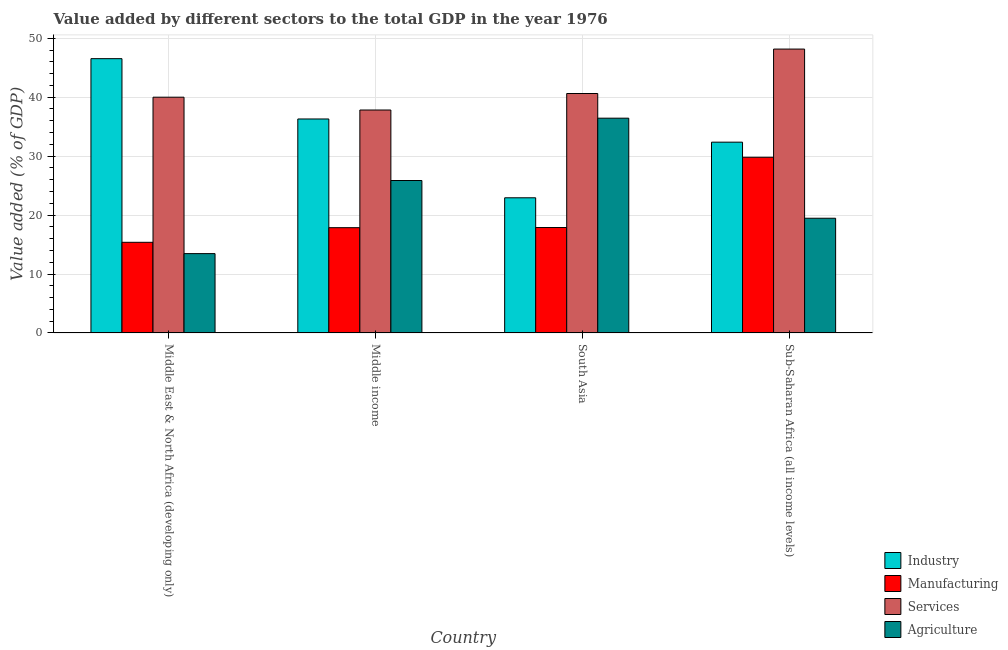Are the number of bars per tick equal to the number of legend labels?
Your answer should be compact. Yes. How many bars are there on the 2nd tick from the right?
Ensure brevity in your answer.  4. What is the label of the 4th group of bars from the left?
Provide a succinct answer. Sub-Saharan Africa (all income levels). What is the value added by manufacturing sector in Middle income?
Offer a very short reply. 17.86. Across all countries, what is the maximum value added by industrial sector?
Offer a very short reply. 46.54. Across all countries, what is the minimum value added by manufacturing sector?
Ensure brevity in your answer.  15.38. In which country was the value added by services sector maximum?
Your response must be concise. Sub-Saharan Africa (all income levels). What is the total value added by agricultural sector in the graph?
Make the answer very short. 95.23. What is the difference between the value added by services sector in Middle East & North Africa (developing only) and that in Sub-Saharan Africa (all income levels)?
Your answer should be compact. -8.17. What is the difference between the value added by industrial sector in Middle income and the value added by services sector in Middle East & North Africa (developing only)?
Your response must be concise. -3.69. What is the average value added by manufacturing sector per country?
Your answer should be very brief. 20.23. What is the difference between the value added by manufacturing sector and value added by agricultural sector in Middle income?
Your answer should be very brief. -8.01. What is the ratio of the value added by services sector in Middle income to that in South Asia?
Your answer should be very brief. 0.93. Is the difference between the value added by services sector in Middle income and Sub-Saharan Africa (all income levels) greater than the difference between the value added by industrial sector in Middle income and Sub-Saharan Africa (all income levels)?
Ensure brevity in your answer.  No. What is the difference between the highest and the second highest value added by services sector?
Offer a very short reply. 7.54. What is the difference between the highest and the lowest value added by manufacturing sector?
Ensure brevity in your answer.  14.43. In how many countries, is the value added by industrial sector greater than the average value added by industrial sector taken over all countries?
Your response must be concise. 2. What does the 1st bar from the left in Middle East & North Africa (developing only) represents?
Offer a very short reply. Industry. What does the 4th bar from the right in South Asia represents?
Your response must be concise. Industry. Is it the case that in every country, the sum of the value added by industrial sector and value added by manufacturing sector is greater than the value added by services sector?
Your response must be concise. Yes. How many bars are there?
Provide a short and direct response. 16. Does the graph contain any zero values?
Provide a succinct answer. No. How many legend labels are there?
Keep it short and to the point. 4. What is the title of the graph?
Provide a succinct answer. Value added by different sectors to the total GDP in the year 1976. What is the label or title of the X-axis?
Ensure brevity in your answer.  Country. What is the label or title of the Y-axis?
Offer a terse response. Value added (% of GDP). What is the Value added (% of GDP) of Industry in Middle East & North Africa (developing only)?
Make the answer very short. 46.54. What is the Value added (% of GDP) in Manufacturing in Middle East & North Africa (developing only)?
Give a very brief answer. 15.38. What is the Value added (% of GDP) in Services in Middle East & North Africa (developing only)?
Your answer should be compact. 40. What is the Value added (% of GDP) of Agriculture in Middle East & North Africa (developing only)?
Keep it short and to the point. 13.46. What is the Value added (% of GDP) in Industry in Middle income?
Your answer should be very brief. 36.31. What is the Value added (% of GDP) in Manufacturing in Middle income?
Your answer should be compact. 17.86. What is the Value added (% of GDP) in Services in Middle income?
Provide a short and direct response. 37.83. What is the Value added (% of GDP) in Agriculture in Middle income?
Offer a very short reply. 25.87. What is the Value added (% of GDP) of Industry in South Asia?
Offer a terse response. 22.93. What is the Value added (% of GDP) in Manufacturing in South Asia?
Give a very brief answer. 17.89. What is the Value added (% of GDP) of Services in South Asia?
Keep it short and to the point. 40.63. What is the Value added (% of GDP) in Agriculture in South Asia?
Give a very brief answer. 36.44. What is the Value added (% of GDP) in Industry in Sub-Saharan Africa (all income levels)?
Offer a very short reply. 32.37. What is the Value added (% of GDP) in Manufacturing in Sub-Saharan Africa (all income levels)?
Your response must be concise. 29.81. What is the Value added (% of GDP) in Services in Sub-Saharan Africa (all income levels)?
Keep it short and to the point. 48.17. What is the Value added (% of GDP) in Agriculture in Sub-Saharan Africa (all income levels)?
Keep it short and to the point. 19.46. Across all countries, what is the maximum Value added (% of GDP) of Industry?
Give a very brief answer. 46.54. Across all countries, what is the maximum Value added (% of GDP) of Manufacturing?
Provide a short and direct response. 29.81. Across all countries, what is the maximum Value added (% of GDP) in Services?
Give a very brief answer. 48.17. Across all countries, what is the maximum Value added (% of GDP) of Agriculture?
Provide a short and direct response. 36.44. Across all countries, what is the minimum Value added (% of GDP) in Industry?
Provide a short and direct response. 22.93. Across all countries, what is the minimum Value added (% of GDP) in Manufacturing?
Make the answer very short. 15.38. Across all countries, what is the minimum Value added (% of GDP) in Services?
Provide a succinct answer. 37.83. Across all countries, what is the minimum Value added (% of GDP) of Agriculture?
Ensure brevity in your answer.  13.46. What is the total Value added (% of GDP) of Industry in the graph?
Provide a succinct answer. 138.15. What is the total Value added (% of GDP) of Manufacturing in the graph?
Provide a succinct answer. 80.93. What is the total Value added (% of GDP) of Services in the graph?
Provide a succinct answer. 166.62. What is the total Value added (% of GDP) in Agriculture in the graph?
Offer a very short reply. 95.23. What is the difference between the Value added (% of GDP) in Industry in Middle East & North Africa (developing only) and that in Middle income?
Make the answer very short. 10.23. What is the difference between the Value added (% of GDP) of Manufacturing in Middle East & North Africa (developing only) and that in Middle income?
Give a very brief answer. -2.48. What is the difference between the Value added (% of GDP) in Services in Middle East & North Africa (developing only) and that in Middle income?
Keep it short and to the point. 2.17. What is the difference between the Value added (% of GDP) of Agriculture in Middle East & North Africa (developing only) and that in Middle income?
Keep it short and to the point. -12.41. What is the difference between the Value added (% of GDP) in Industry in Middle East & North Africa (developing only) and that in South Asia?
Make the answer very short. 23.61. What is the difference between the Value added (% of GDP) of Manufacturing in Middle East & North Africa (developing only) and that in South Asia?
Offer a terse response. -2.51. What is the difference between the Value added (% of GDP) in Services in Middle East & North Africa (developing only) and that in South Asia?
Ensure brevity in your answer.  -0.63. What is the difference between the Value added (% of GDP) of Agriculture in Middle East & North Africa (developing only) and that in South Asia?
Offer a very short reply. -22.98. What is the difference between the Value added (% of GDP) of Industry in Middle East & North Africa (developing only) and that in Sub-Saharan Africa (all income levels)?
Give a very brief answer. 14.17. What is the difference between the Value added (% of GDP) in Manufacturing in Middle East & North Africa (developing only) and that in Sub-Saharan Africa (all income levels)?
Offer a very short reply. -14.43. What is the difference between the Value added (% of GDP) of Services in Middle East & North Africa (developing only) and that in Sub-Saharan Africa (all income levels)?
Your answer should be compact. -8.17. What is the difference between the Value added (% of GDP) of Agriculture in Middle East & North Africa (developing only) and that in Sub-Saharan Africa (all income levels)?
Provide a short and direct response. -6. What is the difference between the Value added (% of GDP) in Industry in Middle income and that in South Asia?
Keep it short and to the point. 13.38. What is the difference between the Value added (% of GDP) in Manufacturing in Middle income and that in South Asia?
Offer a very short reply. -0.03. What is the difference between the Value added (% of GDP) in Services in Middle income and that in South Asia?
Your answer should be very brief. -2.8. What is the difference between the Value added (% of GDP) in Agriculture in Middle income and that in South Asia?
Offer a very short reply. -10.58. What is the difference between the Value added (% of GDP) of Industry in Middle income and that in Sub-Saharan Africa (all income levels)?
Make the answer very short. 3.93. What is the difference between the Value added (% of GDP) in Manufacturing in Middle income and that in Sub-Saharan Africa (all income levels)?
Make the answer very short. -11.95. What is the difference between the Value added (% of GDP) of Services in Middle income and that in Sub-Saharan Africa (all income levels)?
Ensure brevity in your answer.  -10.34. What is the difference between the Value added (% of GDP) in Agriculture in Middle income and that in Sub-Saharan Africa (all income levels)?
Ensure brevity in your answer.  6.4. What is the difference between the Value added (% of GDP) in Industry in South Asia and that in Sub-Saharan Africa (all income levels)?
Your answer should be very brief. -9.44. What is the difference between the Value added (% of GDP) of Manufacturing in South Asia and that in Sub-Saharan Africa (all income levels)?
Provide a short and direct response. -11.92. What is the difference between the Value added (% of GDP) of Services in South Asia and that in Sub-Saharan Africa (all income levels)?
Your answer should be very brief. -7.54. What is the difference between the Value added (% of GDP) in Agriculture in South Asia and that in Sub-Saharan Africa (all income levels)?
Keep it short and to the point. 16.98. What is the difference between the Value added (% of GDP) of Industry in Middle East & North Africa (developing only) and the Value added (% of GDP) of Manufacturing in Middle income?
Provide a short and direct response. 28.68. What is the difference between the Value added (% of GDP) in Industry in Middle East & North Africa (developing only) and the Value added (% of GDP) in Services in Middle income?
Your answer should be very brief. 8.71. What is the difference between the Value added (% of GDP) in Industry in Middle East & North Africa (developing only) and the Value added (% of GDP) in Agriculture in Middle income?
Your answer should be compact. 20.67. What is the difference between the Value added (% of GDP) of Manufacturing in Middle East & North Africa (developing only) and the Value added (% of GDP) of Services in Middle income?
Give a very brief answer. -22.45. What is the difference between the Value added (% of GDP) in Manufacturing in Middle East & North Africa (developing only) and the Value added (% of GDP) in Agriculture in Middle income?
Offer a very short reply. -10.49. What is the difference between the Value added (% of GDP) of Services in Middle East & North Africa (developing only) and the Value added (% of GDP) of Agriculture in Middle income?
Ensure brevity in your answer.  14.13. What is the difference between the Value added (% of GDP) of Industry in Middle East & North Africa (developing only) and the Value added (% of GDP) of Manufacturing in South Asia?
Your answer should be very brief. 28.65. What is the difference between the Value added (% of GDP) in Industry in Middle East & North Africa (developing only) and the Value added (% of GDP) in Services in South Asia?
Provide a short and direct response. 5.91. What is the difference between the Value added (% of GDP) in Industry in Middle East & North Africa (developing only) and the Value added (% of GDP) in Agriculture in South Asia?
Offer a terse response. 10.1. What is the difference between the Value added (% of GDP) of Manufacturing in Middle East & North Africa (developing only) and the Value added (% of GDP) of Services in South Asia?
Provide a short and direct response. -25.25. What is the difference between the Value added (% of GDP) in Manufacturing in Middle East & North Africa (developing only) and the Value added (% of GDP) in Agriculture in South Asia?
Make the answer very short. -21.06. What is the difference between the Value added (% of GDP) of Services in Middle East & North Africa (developing only) and the Value added (% of GDP) of Agriculture in South Asia?
Provide a short and direct response. 3.56. What is the difference between the Value added (% of GDP) of Industry in Middle East & North Africa (developing only) and the Value added (% of GDP) of Manufacturing in Sub-Saharan Africa (all income levels)?
Ensure brevity in your answer.  16.73. What is the difference between the Value added (% of GDP) of Industry in Middle East & North Africa (developing only) and the Value added (% of GDP) of Services in Sub-Saharan Africa (all income levels)?
Your response must be concise. -1.63. What is the difference between the Value added (% of GDP) in Industry in Middle East & North Africa (developing only) and the Value added (% of GDP) in Agriculture in Sub-Saharan Africa (all income levels)?
Keep it short and to the point. 27.08. What is the difference between the Value added (% of GDP) in Manufacturing in Middle East & North Africa (developing only) and the Value added (% of GDP) in Services in Sub-Saharan Africa (all income levels)?
Offer a terse response. -32.79. What is the difference between the Value added (% of GDP) in Manufacturing in Middle East & North Africa (developing only) and the Value added (% of GDP) in Agriculture in Sub-Saharan Africa (all income levels)?
Give a very brief answer. -4.08. What is the difference between the Value added (% of GDP) of Services in Middle East & North Africa (developing only) and the Value added (% of GDP) of Agriculture in Sub-Saharan Africa (all income levels)?
Offer a very short reply. 20.54. What is the difference between the Value added (% of GDP) of Industry in Middle income and the Value added (% of GDP) of Manufacturing in South Asia?
Ensure brevity in your answer.  18.42. What is the difference between the Value added (% of GDP) in Industry in Middle income and the Value added (% of GDP) in Services in South Asia?
Provide a succinct answer. -4.32. What is the difference between the Value added (% of GDP) of Industry in Middle income and the Value added (% of GDP) of Agriculture in South Asia?
Offer a terse response. -0.13. What is the difference between the Value added (% of GDP) of Manufacturing in Middle income and the Value added (% of GDP) of Services in South Asia?
Offer a very short reply. -22.77. What is the difference between the Value added (% of GDP) in Manufacturing in Middle income and the Value added (% of GDP) in Agriculture in South Asia?
Keep it short and to the point. -18.58. What is the difference between the Value added (% of GDP) in Services in Middle income and the Value added (% of GDP) in Agriculture in South Asia?
Your answer should be compact. 1.39. What is the difference between the Value added (% of GDP) in Industry in Middle income and the Value added (% of GDP) in Manufacturing in Sub-Saharan Africa (all income levels)?
Offer a terse response. 6.5. What is the difference between the Value added (% of GDP) in Industry in Middle income and the Value added (% of GDP) in Services in Sub-Saharan Africa (all income levels)?
Provide a short and direct response. -11.86. What is the difference between the Value added (% of GDP) in Industry in Middle income and the Value added (% of GDP) in Agriculture in Sub-Saharan Africa (all income levels)?
Ensure brevity in your answer.  16.85. What is the difference between the Value added (% of GDP) in Manufacturing in Middle income and the Value added (% of GDP) in Services in Sub-Saharan Africa (all income levels)?
Your answer should be compact. -30.31. What is the difference between the Value added (% of GDP) in Manufacturing in Middle income and the Value added (% of GDP) in Agriculture in Sub-Saharan Africa (all income levels)?
Give a very brief answer. -1.6. What is the difference between the Value added (% of GDP) of Services in Middle income and the Value added (% of GDP) of Agriculture in Sub-Saharan Africa (all income levels)?
Your answer should be very brief. 18.37. What is the difference between the Value added (% of GDP) of Industry in South Asia and the Value added (% of GDP) of Manufacturing in Sub-Saharan Africa (all income levels)?
Ensure brevity in your answer.  -6.88. What is the difference between the Value added (% of GDP) of Industry in South Asia and the Value added (% of GDP) of Services in Sub-Saharan Africa (all income levels)?
Offer a terse response. -25.24. What is the difference between the Value added (% of GDP) in Industry in South Asia and the Value added (% of GDP) in Agriculture in Sub-Saharan Africa (all income levels)?
Offer a terse response. 3.47. What is the difference between the Value added (% of GDP) of Manufacturing in South Asia and the Value added (% of GDP) of Services in Sub-Saharan Africa (all income levels)?
Keep it short and to the point. -30.28. What is the difference between the Value added (% of GDP) in Manufacturing in South Asia and the Value added (% of GDP) in Agriculture in Sub-Saharan Africa (all income levels)?
Ensure brevity in your answer.  -1.57. What is the difference between the Value added (% of GDP) in Services in South Asia and the Value added (% of GDP) in Agriculture in Sub-Saharan Africa (all income levels)?
Your response must be concise. 21.17. What is the average Value added (% of GDP) in Industry per country?
Provide a short and direct response. 34.54. What is the average Value added (% of GDP) in Manufacturing per country?
Ensure brevity in your answer.  20.23. What is the average Value added (% of GDP) in Services per country?
Provide a succinct answer. 41.66. What is the average Value added (% of GDP) in Agriculture per country?
Provide a succinct answer. 23.81. What is the difference between the Value added (% of GDP) in Industry and Value added (% of GDP) in Manufacturing in Middle East & North Africa (developing only)?
Your answer should be compact. 31.16. What is the difference between the Value added (% of GDP) of Industry and Value added (% of GDP) of Services in Middle East & North Africa (developing only)?
Give a very brief answer. 6.54. What is the difference between the Value added (% of GDP) in Industry and Value added (% of GDP) in Agriculture in Middle East & North Africa (developing only)?
Offer a terse response. 33.08. What is the difference between the Value added (% of GDP) in Manufacturing and Value added (% of GDP) in Services in Middle East & North Africa (developing only)?
Provide a succinct answer. -24.62. What is the difference between the Value added (% of GDP) in Manufacturing and Value added (% of GDP) in Agriculture in Middle East & North Africa (developing only)?
Give a very brief answer. 1.92. What is the difference between the Value added (% of GDP) of Services and Value added (% of GDP) of Agriculture in Middle East & North Africa (developing only)?
Offer a terse response. 26.54. What is the difference between the Value added (% of GDP) of Industry and Value added (% of GDP) of Manufacturing in Middle income?
Your answer should be very brief. 18.45. What is the difference between the Value added (% of GDP) in Industry and Value added (% of GDP) in Services in Middle income?
Provide a short and direct response. -1.52. What is the difference between the Value added (% of GDP) in Industry and Value added (% of GDP) in Agriculture in Middle income?
Ensure brevity in your answer.  10.44. What is the difference between the Value added (% of GDP) in Manufacturing and Value added (% of GDP) in Services in Middle income?
Offer a terse response. -19.97. What is the difference between the Value added (% of GDP) of Manufacturing and Value added (% of GDP) of Agriculture in Middle income?
Your response must be concise. -8.01. What is the difference between the Value added (% of GDP) of Services and Value added (% of GDP) of Agriculture in Middle income?
Offer a very short reply. 11.96. What is the difference between the Value added (% of GDP) of Industry and Value added (% of GDP) of Manufacturing in South Asia?
Your answer should be compact. 5.04. What is the difference between the Value added (% of GDP) in Industry and Value added (% of GDP) in Services in South Asia?
Keep it short and to the point. -17.7. What is the difference between the Value added (% of GDP) of Industry and Value added (% of GDP) of Agriculture in South Asia?
Your response must be concise. -13.51. What is the difference between the Value added (% of GDP) of Manufacturing and Value added (% of GDP) of Services in South Asia?
Provide a short and direct response. -22.74. What is the difference between the Value added (% of GDP) of Manufacturing and Value added (% of GDP) of Agriculture in South Asia?
Give a very brief answer. -18.55. What is the difference between the Value added (% of GDP) in Services and Value added (% of GDP) in Agriculture in South Asia?
Your response must be concise. 4.19. What is the difference between the Value added (% of GDP) in Industry and Value added (% of GDP) in Manufacturing in Sub-Saharan Africa (all income levels)?
Your answer should be very brief. 2.56. What is the difference between the Value added (% of GDP) in Industry and Value added (% of GDP) in Services in Sub-Saharan Africa (all income levels)?
Ensure brevity in your answer.  -15.8. What is the difference between the Value added (% of GDP) in Industry and Value added (% of GDP) in Agriculture in Sub-Saharan Africa (all income levels)?
Your answer should be very brief. 12.91. What is the difference between the Value added (% of GDP) in Manufacturing and Value added (% of GDP) in Services in Sub-Saharan Africa (all income levels)?
Your answer should be compact. -18.36. What is the difference between the Value added (% of GDP) of Manufacturing and Value added (% of GDP) of Agriculture in Sub-Saharan Africa (all income levels)?
Keep it short and to the point. 10.35. What is the difference between the Value added (% of GDP) of Services and Value added (% of GDP) of Agriculture in Sub-Saharan Africa (all income levels)?
Your response must be concise. 28.71. What is the ratio of the Value added (% of GDP) of Industry in Middle East & North Africa (developing only) to that in Middle income?
Your response must be concise. 1.28. What is the ratio of the Value added (% of GDP) of Manufacturing in Middle East & North Africa (developing only) to that in Middle income?
Your answer should be compact. 0.86. What is the ratio of the Value added (% of GDP) of Services in Middle East & North Africa (developing only) to that in Middle income?
Your answer should be very brief. 1.06. What is the ratio of the Value added (% of GDP) in Agriculture in Middle East & North Africa (developing only) to that in Middle income?
Your answer should be very brief. 0.52. What is the ratio of the Value added (% of GDP) in Industry in Middle East & North Africa (developing only) to that in South Asia?
Provide a succinct answer. 2.03. What is the ratio of the Value added (% of GDP) of Manufacturing in Middle East & North Africa (developing only) to that in South Asia?
Give a very brief answer. 0.86. What is the ratio of the Value added (% of GDP) of Services in Middle East & North Africa (developing only) to that in South Asia?
Ensure brevity in your answer.  0.98. What is the ratio of the Value added (% of GDP) of Agriculture in Middle East & North Africa (developing only) to that in South Asia?
Your answer should be compact. 0.37. What is the ratio of the Value added (% of GDP) of Industry in Middle East & North Africa (developing only) to that in Sub-Saharan Africa (all income levels)?
Ensure brevity in your answer.  1.44. What is the ratio of the Value added (% of GDP) of Manufacturing in Middle East & North Africa (developing only) to that in Sub-Saharan Africa (all income levels)?
Provide a succinct answer. 0.52. What is the ratio of the Value added (% of GDP) of Services in Middle East & North Africa (developing only) to that in Sub-Saharan Africa (all income levels)?
Offer a very short reply. 0.83. What is the ratio of the Value added (% of GDP) in Agriculture in Middle East & North Africa (developing only) to that in Sub-Saharan Africa (all income levels)?
Provide a succinct answer. 0.69. What is the ratio of the Value added (% of GDP) of Industry in Middle income to that in South Asia?
Provide a short and direct response. 1.58. What is the ratio of the Value added (% of GDP) in Manufacturing in Middle income to that in South Asia?
Offer a very short reply. 1. What is the ratio of the Value added (% of GDP) of Services in Middle income to that in South Asia?
Your response must be concise. 0.93. What is the ratio of the Value added (% of GDP) in Agriculture in Middle income to that in South Asia?
Provide a short and direct response. 0.71. What is the ratio of the Value added (% of GDP) in Industry in Middle income to that in Sub-Saharan Africa (all income levels)?
Keep it short and to the point. 1.12. What is the ratio of the Value added (% of GDP) of Manufacturing in Middle income to that in Sub-Saharan Africa (all income levels)?
Provide a short and direct response. 0.6. What is the ratio of the Value added (% of GDP) of Services in Middle income to that in Sub-Saharan Africa (all income levels)?
Ensure brevity in your answer.  0.79. What is the ratio of the Value added (% of GDP) of Agriculture in Middle income to that in Sub-Saharan Africa (all income levels)?
Offer a very short reply. 1.33. What is the ratio of the Value added (% of GDP) in Industry in South Asia to that in Sub-Saharan Africa (all income levels)?
Provide a succinct answer. 0.71. What is the ratio of the Value added (% of GDP) in Manufacturing in South Asia to that in Sub-Saharan Africa (all income levels)?
Give a very brief answer. 0.6. What is the ratio of the Value added (% of GDP) of Services in South Asia to that in Sub-Saharan Africa (all income levels)?
Keep it short and to the point. 0.84. What is the ratio of the Value added (% of GDP) of Agriculture in South Asia to that in Sub-Saharan Africa (all income levels)?
Your response must be concise. 1.87. What is the difference between the highest and the second highest Value added (% of GDP) in Industry?
Provide a short and direct response. 10.23. What is the difference between the highest and the second highest Value added (% of GDP) in Manufacturing?
Your answer should be compact. 11.92. What is the difference between the highest and the second highest Value added (% of GDP) of Services?
Make the answer very short. 7.54. What is the difference between the highest and the second highest Value added (% of GDP) in Agriculture?
Provide a succinct answer. 10.58. What is the difference between the highest and the lowest Value added (% of GDP) in Industry?
Offer a very short reply. 23.61. What is the difference between the highest and the lowest Value added (% of GDP) of Manufacturing?
Your answer should be compact. 14.43. What is the difference between the highest and the lowest Value added (% of GDP) in Services?
Provide a succinct answer. 10.34. What is the difference between the highest and the lowest Value added (% of GDP) of Agriculture?
Offer a terse response. 22.98. 